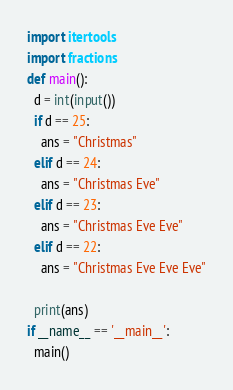Convert code to text. <code><loc_0><loc_0><loc_500><loc_500><_Python_>import itertools
import fractions
def main():
  d = int(input())
  if d == 25:
    ans = "Christmas"
  elif d == 24:
    ans = "Christmas Eve"
  elif d == 23:
    ans = "Christmas Eve Eve"
  elif d == 22:
    ans = "Christmas Eve Eve Eve"
  
  print(ans)
if __name__ == '__main__':
  main()</code> 